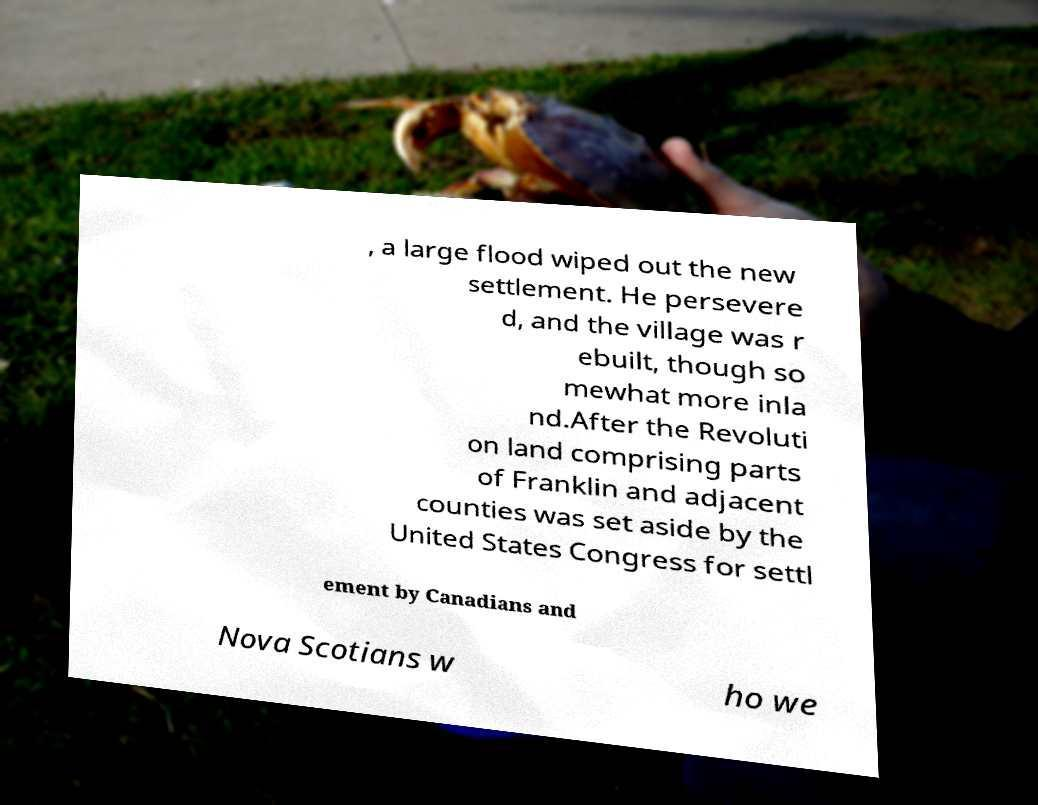There's text embedded in this image that I need extracted. Can you transcribe it verbatim? , a large flood wiped out the new settlement. He persevere d, and the village was r ebuilt, though so mewhat more inla nd.After the Revoluti on land comprising parts of Franklin and adjacent counties was set aside by the United States Congress for settl ement by Canadians and Nova Scotians w ho we 